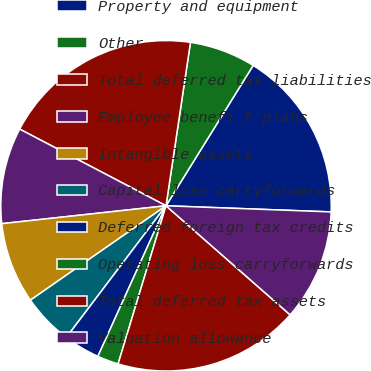Convert chart. <chart><loc_0><loc_0><loc_500><loc_500><pie_chart><fcel>Property and equipment<fcel>Other<fcel>Total deferred tax liabilities<fcel>Employee benefi t plans<fcel>Intangible assets<fcel>Capital loss carryforwards<fcel>Deferred foreign tax credits<fcel>Operating loss carryforwards<fcel>Total deferred tax assets<fcel>Valuation allowance<nl><fcel>16.75%<fcel>6.48%<fcel>19.68%<fcel>9.41%<fcel>7.95%<fcel>5.01%<fcel>3.55%<fcel>2.08%<fcel>18.21%<fcel>10.88%<nl></chart> 